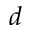<formula> <loc_0><loc_0><loc_500><loc_500>d</formula> 